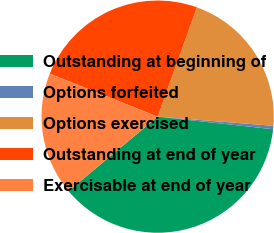Convert chart to OTSL. <chart><loc_0><loc_0><loc_500><loc_500><pie_chart><fcel>Outstanding at beginning of<fcel>Options forfeited<fcel>Options exercised<fcel>Outstanding at end of year<fcel>Exercisable at end of year<nl><fcel>37.19%<fcel>0.47%<fcel>20.78%<fcel>24.45%<fcel>17.11%<nl></chart> 